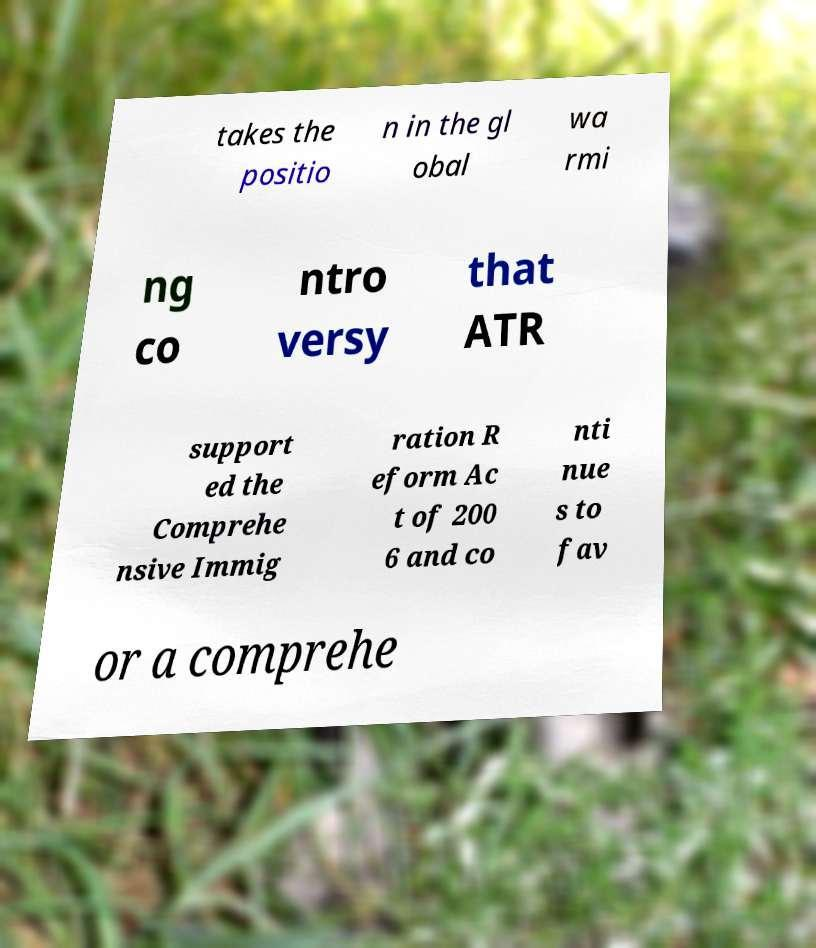Could you assist in decoding the text presented in this image and type it out clearly? takes the positio n in the gl obal wa rmi ng co ntro versy that ATR support ed the Comprehe nsive Immig ration R eform Ac t of 200 6 and co nti nue s to fav or a comprehe 